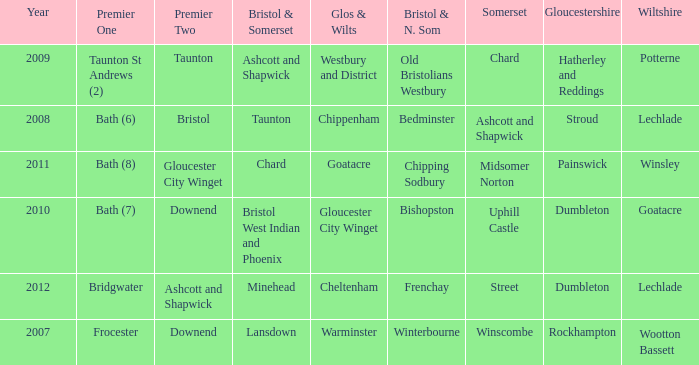Could you help me parse every detail presented in this table? {'header': ['Year', 'Premier One', 'Premier Two', 'Bristol & Somerset', 'Glos & Wilts', 'Bristol & N. Som', 'Somerset', 'Gloucestershire', 'Wiltshire'], 'rows': [['2009', 'Taunton St Andrews (2)', 'Taunton', 'Ashcott and Shapwick', 'Westbury and District', 'Old Bristolians Westbury', 'Chard', 'Hatherley and Reddings', 'Potterne'], ['2008', 'Bath (6)', 'Bristol', 'Taunton', 'Chippenham', 'Bedminster', 'Ashcott and Shapwick', 'Stroud', 'Lechlade'], ['2011', 'Bath (8)', 'Gloucester City Winget', 'Chard', 'Goatacre', 'Chipping Sodbury', 'Midsomer Norton', 'Painswick', 'Winsley'], ['2010', 'Bath (7)', 'Downend', 'Bristol West Indian and Phoenix', 'Gloucester City Winget', 'Bishopston', 'Uphill Castle', 'Dumbleton', 'Goatacre'], ['2012', 'Bridgwater', 'Ashcott and Shapwick', 'Minehead', 'Cheltenham', 'Frenchay', 'Street', 'Dumbleton', 'Lechlade'], ['2007', 'Frocester', 'Downend', 'Lansdown', 'Warminster', 'Winterbourne', 'Winscombe', 'Rockhampton', 'Wootton Bassett']]} What is the latest year where glos & wilts is warminster? 2007.0. 